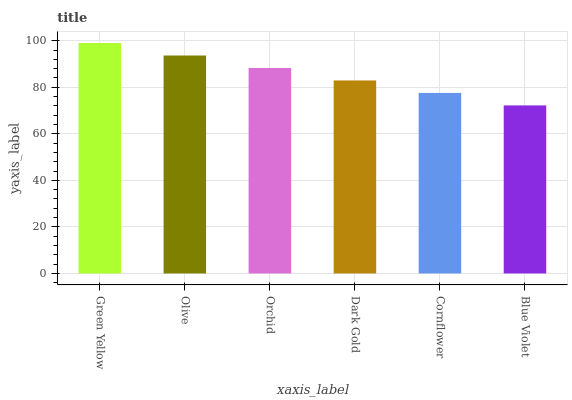Is Blue Violet the minimum?
Answer yes or no. Yes. Is Green Yellow the maximum?
Answer yes or no. Yes. Is Olive the minimum?
Answer yes or no. No. Is Olive the maximum?
Answer yes or no. No. Is Green Yellow greater than Olive?
Answer yes or no. Yes. Is Olive less than Green Yellow?
Answer yes or no. Yes. Is Olive greater than Green Yellow?
Answer yes or no. No. Is Green Yellow less than Olive?
Answer yes or no. No. Is Orchid the high median?
Answer yes or no. Yes. Is Dark Gold the low median?
Answer yes or no. Yes. Is Blue Violet the high median?
Answer yes or no. No. Is Cornflower the low median?
Answer yes or no. No. 